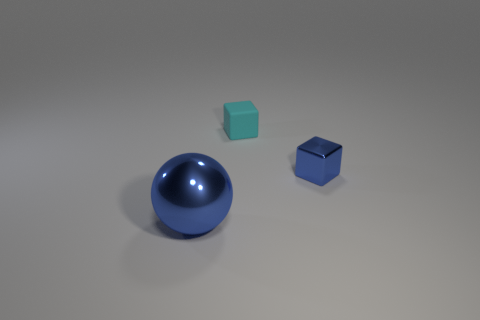Are there any other things that are the same material as the cyan block?
Provide a short and direct response. No. Is there a object of the same color as the shiny sphere?
Offer a very short reply. Yes. Are there the same number of small metal objects that are behind the cyan cube and big cyan rubber things?
Offer a terse response. Yes. How many large balls have the same material as the blue cube?
Ensure brevity in your answer.  1. Is the number of cyan matte cubes less than the number of cubes?
Offer a terse response. Yes. There is a shiny ball in front of the tiny blue metal cube; does it have the same color as the small metal thing?
Give a very brief answer. Yes. What number of big objects are behind the block to the left of the small block in front of the tiny rubber thing?
Your answer should be compact. 0. How many metal things are on the left side of the small blue metal block?
Offer a terse response. 1. The small matte object that is the same shape as the tiny blue metal object is what color?
Keep it short and to the point. Cyan. The thing that is both to the right of the big blue thing and in front of the small cyan matte block is made of what material?
Keep it short and to the point. Metal. 